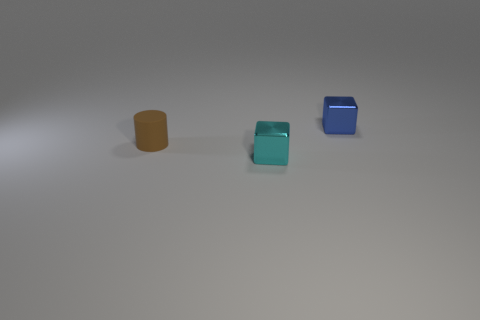Is there a cyan metallic object of the same size as the cyan metallic block?
Offer a terse response. No. What is the material of the cylinder that is the same size as the blue thing?
Provide a succinct answer. Rubber. What size is the shiny cube behind the tiny brown matte thing?
Your answer should be very brief. Small. What size is the brown cylinder?
Keep it short and to the point. Small. There is a brown object; is it the same size as the metallic cube in front of the small brown cylinder?
Your response must be concise. Yes. There is a small shiny block left of the object right of the tiny cyan metal thing; what is its color?
Offer a very short reply. Cyan. Are there the same number of cyan shiny objects behind the cyan cube and brown matte cylinders that are right of the small blue object?
Make the answer very short. Yes. Do the block that is on the right side of the cyan object and the tiny brown cylinder have the same material?
Provide a short and direct response. No. What is the color of the thing that is both to the left of the small blue object and to the right of the brown rubber cylinder?
Offer a terse response. Cyan. There is a metal object that is on the left side of the blue metallic object; what number of blue blocks are to the left of it?
Provide a succinct answer. 0. 